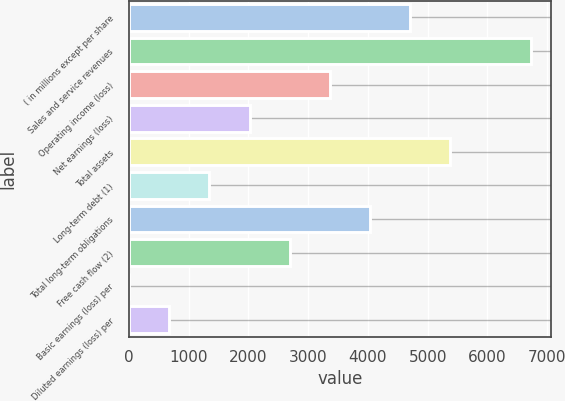<chart> <loc_0><loc_0><loc_500><loc_500><bar_chart><fcel>( in millions except per share<fcel>Sales and service revenues<fcel>Operating income (loss)<fcel>Net earnings (loss)<fcel>Total assets<fcel>Long-term debt (1)<fcel>Total long-term obligations<fcel>Free cash flow (2)<fcel>Basic earnings (loss) per<fcel>Diluted earnings (loss) per<nl><fcel>4706.89<fcel>6723<fcel>3362.83<fcel>2018.77<fcel>5378.92<fcel>1346.74<fcel>4034.86<fcel>2690.8<fcel>2.68<fcel>674.71<nl></chart> 